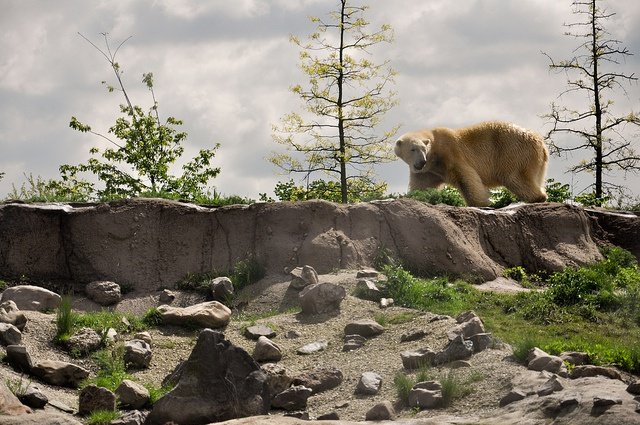Describe the objects in this image and their specific colors. I can see a bear in darkgray, maroon, black, and gray tones in this image. 